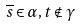<formula> <loc_0><loc_0><loc_500><loc_500>\overline { s } \in \alpha , t \notin \gamma</formula> 